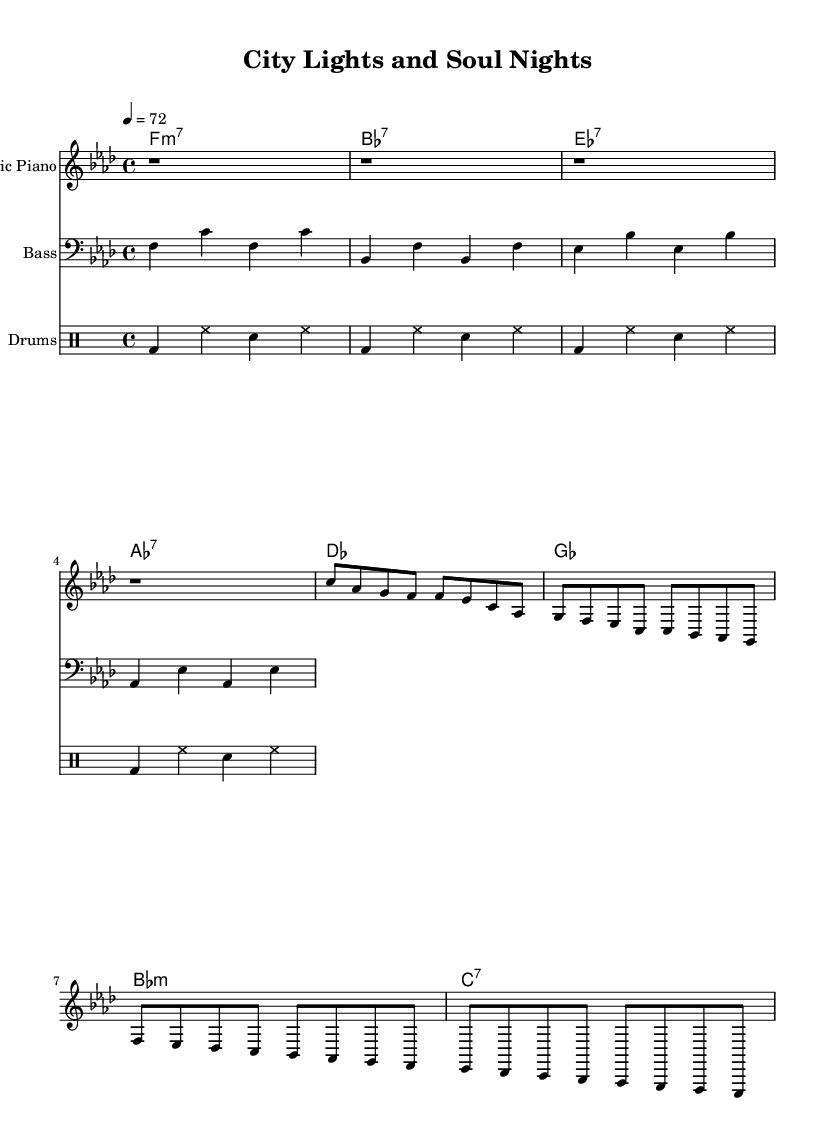What is the key signature of this music? The key signature is indicated at the beginning of the staff. In this sheet music, there are four flats, which corresponds to the key of F minor.
Answer: F minor What is the time signature of this music? The time signature is located at the beginning of the piece and shows how the beats are organized. In this sheet music, it shows 4 over 4, indicating four beats in each measure.
Answer: 4/4 What is the tempo marking for this piece? The tempo marking is specified at the beginning of the music, indicating the speed. Here, it is indicated as quarter note equals 72 beats per minute.
Answer: 72 How many measures are there for the electric piano part? To find this, we can count the number of vertical lines (bar lines) in the electric piano section. There are 8 measures in the electric piano part.
Answer: 8 What type of chords are present in the chords part? By examining the chord symbols written in the chord part, we can identify the types of chords used. The chords consist of minor 7th, dominant 7th, and major chords.
Answer: Minor 7th, Dominant 7th, Major Which instrument provides the bass line in this music? The bass line is indicated by the clef used and the instrument name at the beginning of the bass guitar staff. Here, it shows that a bass guitar is providing the bass line.
Answer: Bass guitar 